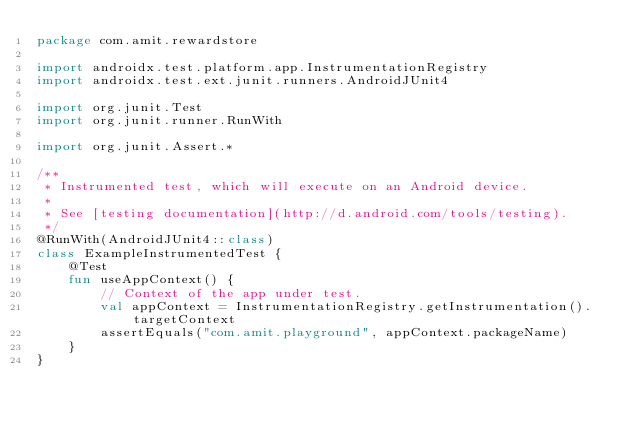Convert code to text. <code><loc_0><loc_0><loc_500><loc_500><_Kotlin_>package com.amit.rewardstore

import androidx.test.platform.app.InstrumentationRegistry
import androidx.test.ext.junit.runners.AndroidJUnit4

import org.junit.Test
import org.junit.runner.RunWith

import org.junit.Assert.*

/**
 * Instrumented test, which will execute on an Android device.
 *
 * See [testing documentation](http://d.android.com/tools/testing).
 */
@RunWith(AndroidJUnit4::class)
class ExampleInstrumentedTest {
    @Test
    fun useAppContext() {
        // Context of the app under test.
        val appContext = InstrumentationRegistry.getInstrumentation().targetContext
        assertEquals("com.amit.playground", appContext.packageName)
    }
}</code> 